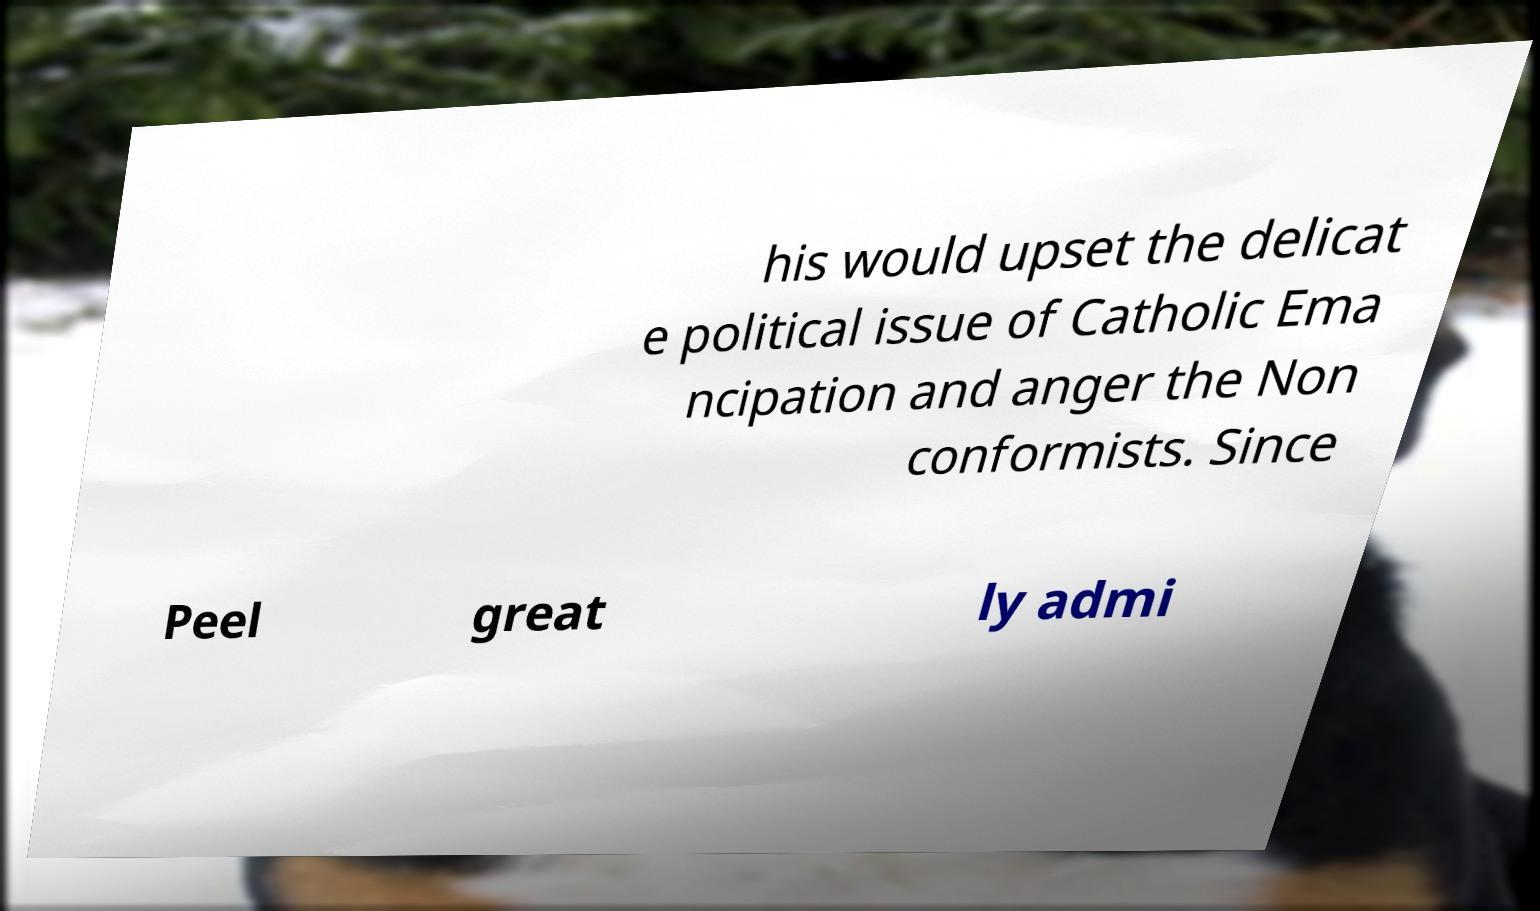Could you assist in decoding the text presented in this image and type it out clearly? his would upset the delicat e political issue of Catholic Ema ncipation and anger the Non conformists. Since Peel great ly admi 